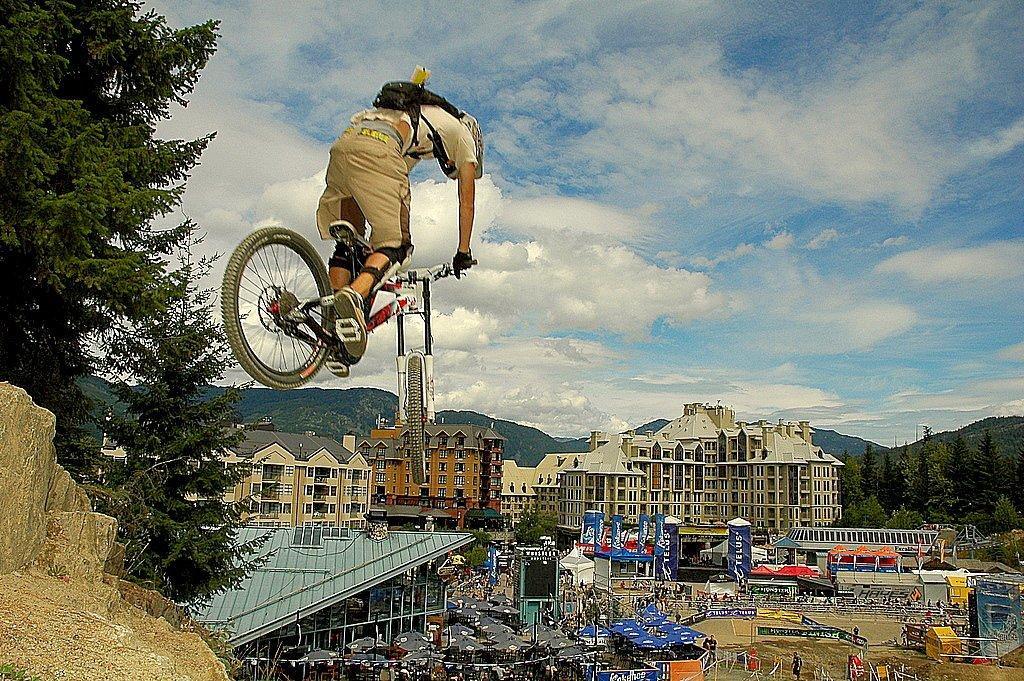In one or two sentences, can you explain what this image depicts? In this image there is a man riding bicycle. He is in the air. He is wearing gloves, knee pads and a bag. At the bottom there are buildings, banners and table umbrellas on the ground. On the either sides of the image there are trees. In the background there are mountains. At the top there is the sky. There are clouds in the sky. 